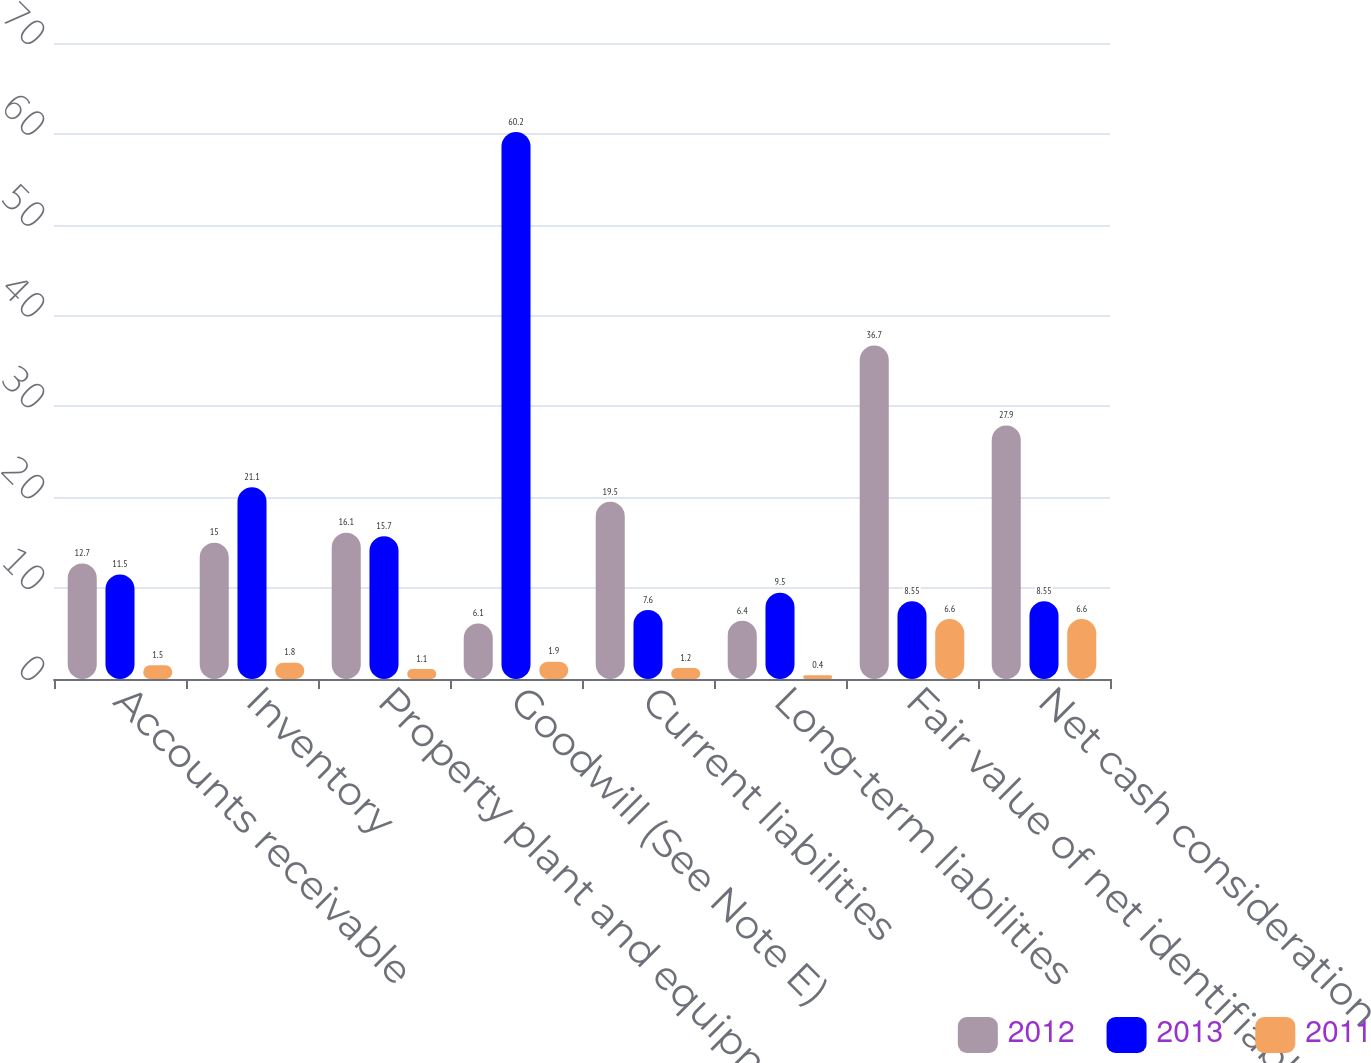Convert chart to OTSL. <chart><loc_0><loc_0><loc_500><loc_500><stacked_bar_chart><ecel><fcel>Accounts receivable<fcel>Inventory<fcel>Property plant and equipment<fcel>Goodwill (See Note E)<fcel>Current liabilities<fcel>Long-term liabilities<fcel>Fair value of net identifiable<fcel>Net cash consideration<nl><fcel>2012<fcel>12.7<fcel>15<fcel>16.1<fcel>6.1<fcel>19.5<fcel>6.4<fcel>36.7<fcel>27.9<nl><fcel>2013<fcel>11.5<fcel>21.1<fcel>15.7<fcel>60.2<fcel>7.6<fcel>9.5<fcel>8.55<fcel>8.55<nl><fcel>2011<fcel>1.5<fcel>1.8<fcel>1.1<fcel>1.9<fcel>1.2<fcel>0.4<fcel>6.6<fcel>6.6<nl></chart> 